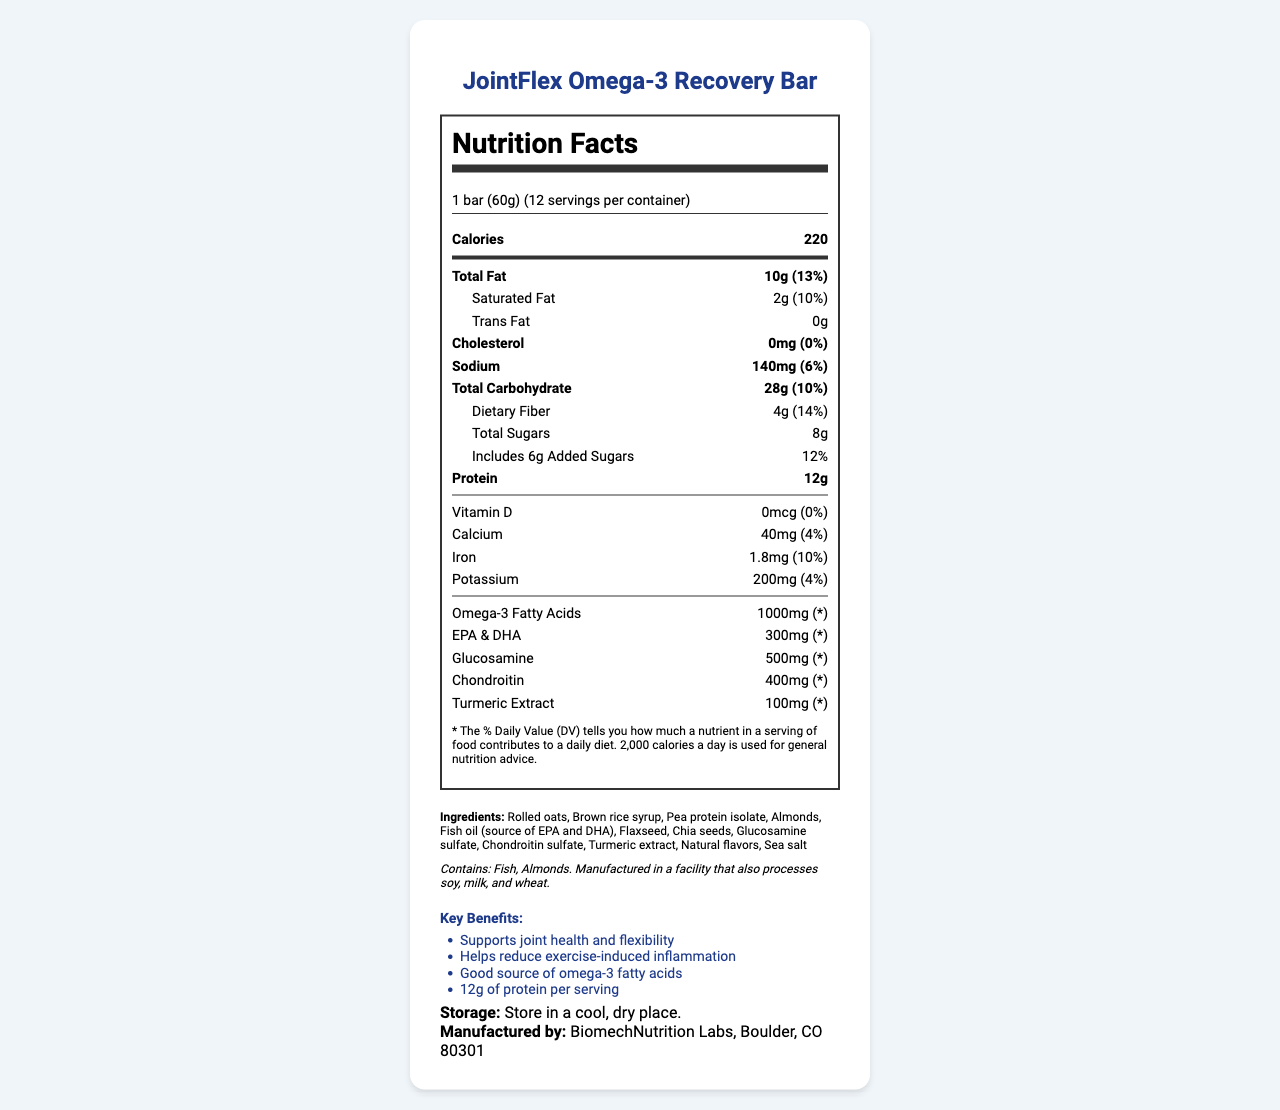what is the serving size of the JointFlex Omega-3 Recovery Bar? The serving size is explicitly stated in the document.
Answer: 1 bar (60g) how many servings are there per container? The document mentions that there are 12 servings per container.
Answer: 12 how much total fat is in one bar? The amount of total fat per serving is listed as 10g in the nutrient information.
Answer: 10g what is the daily value percentage for saturated fat? The daily value percentage for saturated fat is shown as 10%.
Answer: 10% what is the amount of dietary fiber in one serving? The amount of dietary fiber per serving is 4g according to the nutrient information.
Answer: 4g how many grams of total sugars are in one bar? A. 4g B. 6g C. 8g D. 10g The document specifies the total sugars in one bar as 8g.
Answer: C. 8g which of the following is NOT an ingredient in the bar? I. Fish oil II. Soy protein isolate III. Almonds Soy protein isolate is not listed among the ingredients; instead, pea protein isolate is.
Answer: II. Soy protein isolate does the product contain any allergens? The allergen information section states that the bar contains fish and almonds.
Answer: Yes is there any trans fat in the JointFlex Omega-3 Recovery Bar? The document lists the trans fat content as 0g.
Answer: No please summarize the key nutritional benefits and features of the JointFlex Omega-3 Recovery Bar. This summary covers the main features of the bar, including its nutritional content and advertised benefits.
Answer: The JointFlex Omega-3 Recovery Bar supports joint health and flexibility and helps reduce exercise-induced inflammation. It is a good source of omega-3 fatty acids, providing 1000mg per serving, along with other beneficial ingredients like glucosamine, chondroitin, and turmeric extract. The bar offers 220 calories, 10g of fat (2g saturated fat), 28g of carbohydrates (4g dietary fiber and 8g total sugars), and 12g of protein per serving. where is the JointFlex Omega-3 Recovery Bar manufactured? The document states that the manufacturer is BiomechNutrition Labs located in Boulder, CO 80301.
Answer: Boulder, CO 80301 how much calcium does one bar contain? A. 20mg B. 30mg C. 40mg D. 50mg The calcium content is provided as 40mg per serving.
Answer: C. 40mg does the bar contain any Vitamin D? True or False According to the document, the bar contains 0mcg of Vitamin D.
Answer: False what is the combined amount of EPA and DHA in the bar? The document lists that the combined amount of EPA and DHA is 300mg.
Answer: 300mg what is the storage recommendation for the JointFlex Omega-3 Recovery Bar? The storage instructions are specified as storing the bar in a cool, dry place.
Answer: Store in a cool, dry place. how much chondroitin does one bar contain as a percentage of the daily value? The document does not provide a percentage daily value for chondroitin, only the amount (400mg).
Answer: I don't know 